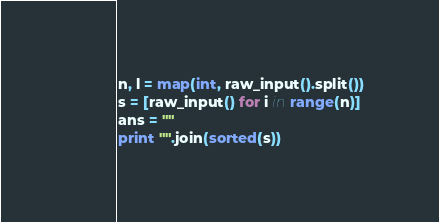<code> <loc_0><loc_0><loc_500><loc_500><_Python_>n, l = map(int, raw_input().split())
s = [raw_input() for i in range(n)]
ans = ""
print "".join(sorted(s))</code> 